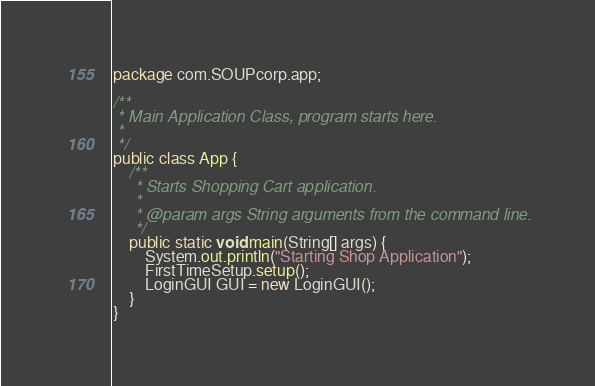Convert code to text. <code><loc_0><loc_0><loc_500><loc_500><_Java_>package com.SOUPcorp.app;

/**
 * Main Application Class, program starts here.
 *
 */
public class App {
    /**
     * Starts Shopping Cart application.
     *
     * @param args String arguments from the command line.
     */
    public static void main(String[] args) {
        System.out.println("Starting Shop Application");
        FirstTimeSetup.setup();
        LoginGUI GUI = new LoginGUI();
    }
}
</code> 